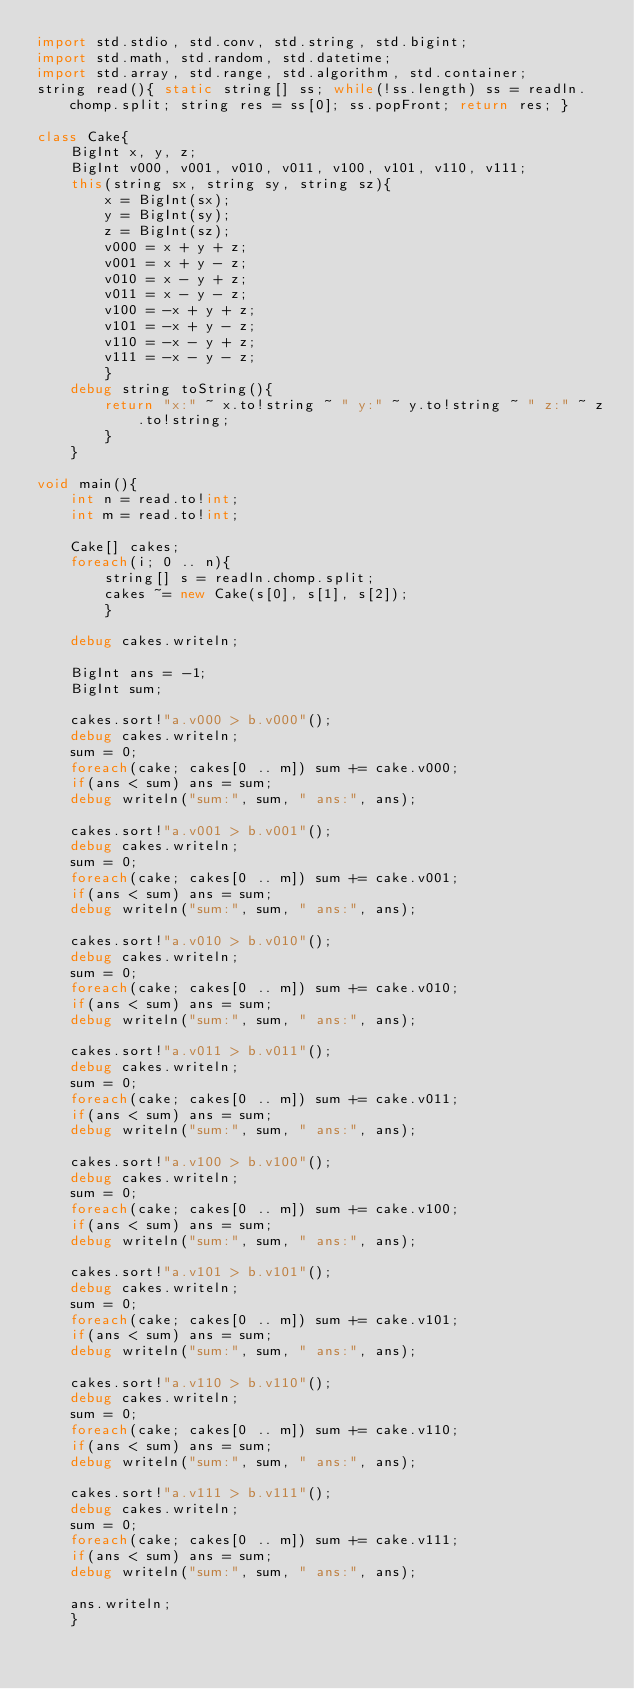Convert code to text. <code><loc_0><loc_0><loc_500><loc_500><_D_>import std.stdio, std.conv, std.string, std.bigint;
import std.math, std.random, std.datetime;
import std.array, std.range, std.algorithm, std.container;
string read(){ static string[] ss; while(!ss.length) ss = readln.chomp.split; string res = ss[0]; ss.popFront; return res; }

class Cake{
	BigInt x, y, z;
	BigInt v000, v001, v010, v011, v100, v101, v110, v111;
	this(string sx, string sy, string sz){
		x = BigInt(sx);
		y = BigInt(sy);
		z = BigInt(sz);
		v000 = x + y + z;
		v001 = x + y - z;
		v010 = x - y + z;
		v011 = x - y - z;
		v100 = -x + y + z;
		v101 = -x + y - z;
		v110 = -x - y + z;
		v111 = -x - y - z;
		}
	debug string toString(){
		return "x:" ~ x.to!string ~ " y:" ~ y.to!string ~ " z:" ~ z.to!string;
		}
	}

void main(){
	int n = read.to!int;
	int m = read.to!int;
	
	Cake[] cakes;
	foreach(i; 0 .. n){
		string[] s = readln.chomp.split;
		cakes ~= new Cake(s[0], s[1], s[2]);
		}
	
	debug cakes.writeln;
	
	BigInt ans = -1;
	BigInt sum;
	
	cakes.sort!"a.v000 > b.v000"();
	debug cakes.writeln;
	sum = 0;
	foreach(cake; cakes[0 .. m]) sum += cake.v000;
	if(ans < sum) ans = sum;
	debug writeln("sum:", sum, " ans:", ans);
	
	cakes.sort!"a.v001 > b.v001"();
	debug cakes.writeln;
	sum = 0;
	foreach(cake; cakes[0 .. m]) sum += cake.v001;
	if(ans < sum) ans = sum;
	debug writeln("sum:", sum, " ans:", ans);
	
	cakes.sort!"a.v010 > b.v010"();
	debug cakes.writeln;
	sum = 0;
	foreach(cake; cakes[0 .. m]) sum += cake.v010;
	if(ans < sum) ans = sum;
	debug writeln("sum:", sum, " ans:", ans);
	
	cakes.sort!"a.v011 > b.v011"();
	debug cakes.writeln;
	sum = 0;
	foreach(cake; cakes[0 .. m]) sum += cake.v011;
	if(ans < sum) ans = sum;
	debug writeln("sum:", sum, " ans:", ans);
	
	cakes.sort!"a.v100 > b.v100"();
	debug cakes.writeln;
	sum = 0;
	foreach(cake; cakes[0 .. m]) sum += cake.v100;
	if(ans < sum) ans = sum;
	debug writeln("sum:", sum, " ans:", ans);
	
	cakes.sort!"a.v101 > b.v101"();
	debug cakes.writeln;
	sum = 0;
	foreach(cake; cakes[0 .. m]) sum += cake.v101;
	if(ans < sum) ans = sum;
	debug writeln("sum:", sum, " ans:", ans);
	
	cakes.sort!"a.v110 > b.v110"();
	debug cakes.writeln;
	sum = 0;
	foreach(cake; cakes[0 .. m]) sum += cake.v110;
	if(ans < sum) ans = sum;
	debug writeln("sum:", sum, " ans:", ans);
	
	cakes.sort!"a.v111 > b.v111"();
	debug cakes.writeln;
	sum = 0;
	foreach(cake; cakes[0 .. m]) sum += cake.v111;
	if(ans < sum) ans = sum;
	debug writeln("sum:", sum, " ans:", ans);
	
	ans.writeln;
	}</code> 